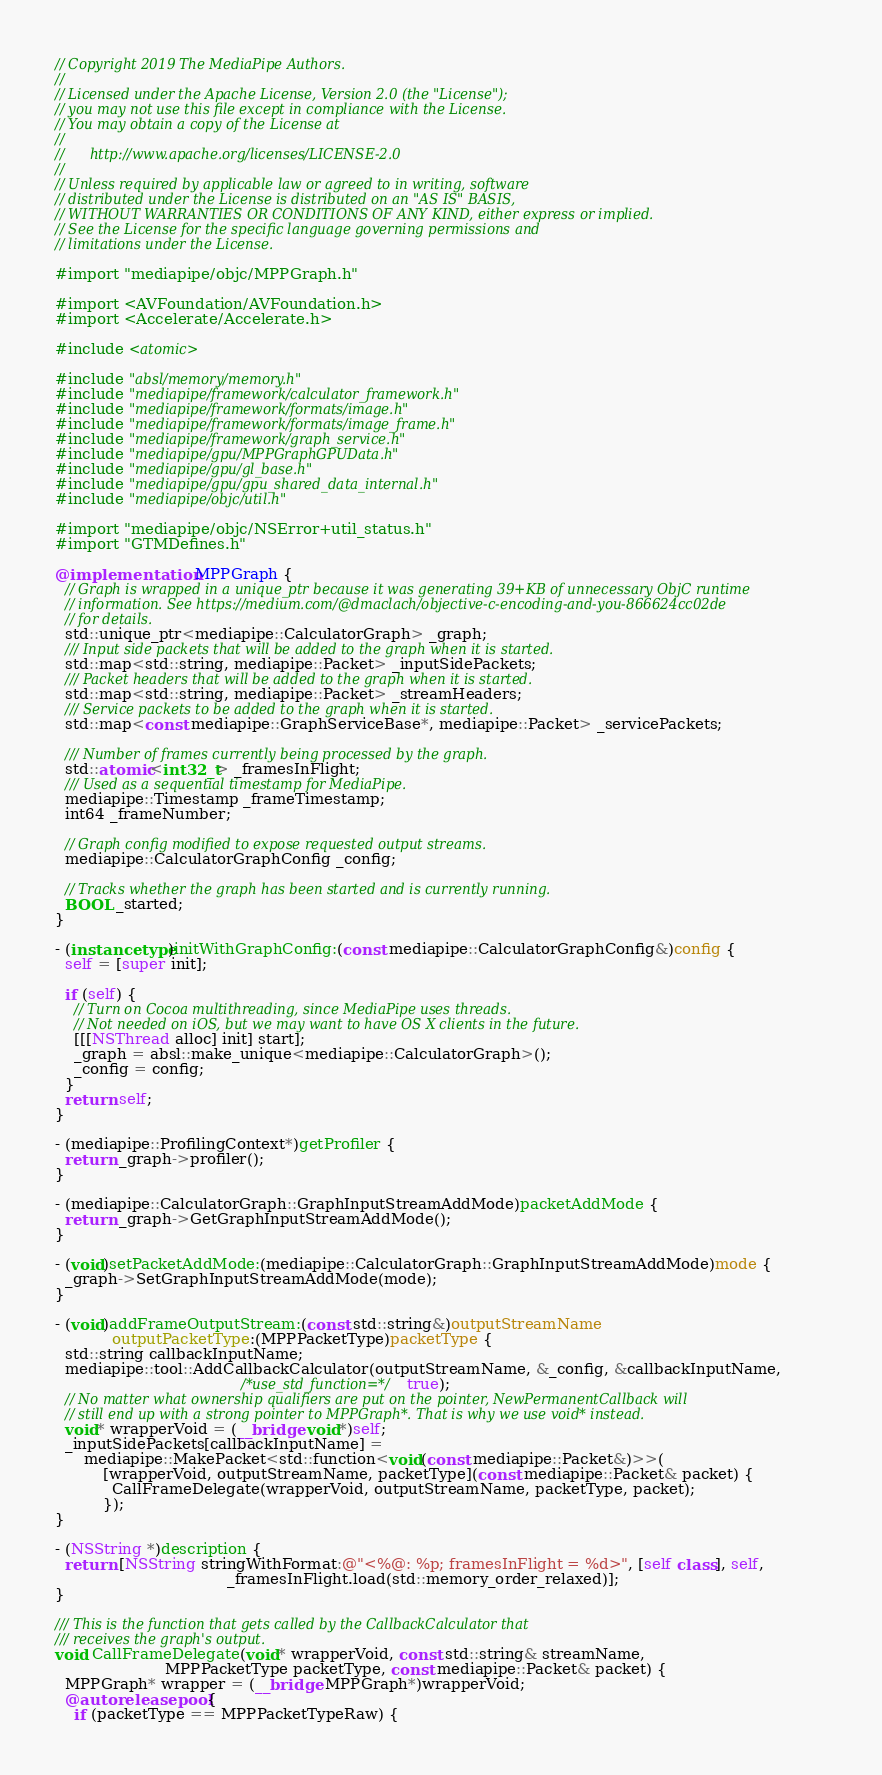<code> <loc_0><loc_0><loc_500><loc_500><_ObjectiveC_>// Copyright 2019 The MediaPipe Authors.
//
// Licensed under the Apache License, Version 2.0 (the "License");
// you may not use this file except in compliance with the License.
// You may obtain a copy of the License at
//
//      http://www.apache.org/licenses/LICENSE-2.0
//
// Unless required by applicable law or agreed to in writing, software
// distributed under the License is distributed on an "AS IS" BASIS,
// WITHOUT WARRANTIES OR CONDITIONS OF ANY KIND, either express or implied.
// See the License for the specific language governing permissions and
// limitations under the License.

#import "mediapipe/objc/MPPGraph.h"

#import <AVFoundation/AVFoundation.h>
#import <Accelerate/Accelerate.h>

#include <atomic>

#include "absl/memory/memory.h"
#include "mediapipe/framework/calculator_framework.h"
#include "mediapipe/framework/formats/image.h"
#include "mediapipe/framework/formats/image_frame.h"
#include "mediapipe/framework/graph_service.h"
#include "mediapipe/gpu/MPPGraphGPUData.h"
#include "mediapipe/gpu/gl_base.h"
#include "mediapipe/gpu/gpu_shared_data_internal.h"
#include "mediapipe/objc/util.h"

#import "mediapipe/objc/NSError+util_status.h"
#import "GTMDefines.h"

@implementation MPPGraph {
  // Graph is wrapped in a unique_ptr because it was generating 39+KB of unnecessary ObjC runtime
  // information. See https://medium.com/@dmaclach/objective-c-encoding-and-you-866624cc02de
  // for details.
  std::unique_ptr<mediapipe::CalculatorGraph> _graph;
  /// Input side packets that will be added to the graph when it is started.
  std::map<std::string, mediapipe::Packet> _inputSidePackets;
  /// Packet headers that will be added to the graph when it is started.
  std::map<std::string, mediapipe::Packet> _streamHeaders;
  /// Service packets to be added to the graph when it is started.
  std::map<const mediapipe::GraphServiceBase*, mediapipe::Packet> _servicePackets;

  /// Number of frames currently being processed by the graph.
  std::atomic<int32_t> _framesInFlight;
  /// Used as a sequential timestamp for MediaPipe.
  mediapipe::Timestamp _frameTimestamp;
  int64 _frameNumber;

  // Graph config modified to expose requested output streams.
  mediapipe::CalculatorGraphConfig _config;

  // Tracks whether the graph has been started and is currently running.
  BOOL _started;
}

- (instancetype)initWithGraphConfig:(const mediapipe::CalculatorGraphConfig&)config {
  self = [super init];

  if (self) {
    // Turn on Cocoa multithreading, since MediaPipe uses threads.
    // Not needed on iOS, but we may want to have OS X clients in the future.
    [[[NSThread alloc] init] start];
    _graph = absl::make_unique<mediapipe::CalculatorGraph>();
    _config = config;
  }
  return self;
}

- (mediapipe::ProfilingContext*)getProfiler {
  return _graph->profiler();
}

- (mediapipe::CalculatorGraph::GraphInputStreamAddMode)packetAddMode {
  return _graph->GetGraphInputStreamAddMode();
}

- (void)setPacketAddMode:(mediapipe::CalculatorGraph::GraphInputStreamAddMode)mode {
  _graph->SetGraphInputStreamAddMode(mode);
}

- (void)addFrameOutputStream:(const std::string&)outputStreamName
            outputPacketType:(MPPPacketType)packetType {
  std::string callbackInputName;
  mediapipe::tool::AddCallbackCalculator(outputStreamName, &_config, &callbackInputName,
                                       /*use_std_function=*/true);
  // No matter what ownership qualifiers are put on the pointer, NewPermanentCallback will
  // still end up with a strong pointer to MPPGraph*. That is why we use void* instead.
  void* wrapperVoid = (__bridge void*)self;
  _inputSidePackets[callbackInputName] =
      mediapipe::MakePacket<std::function<void(const mediapipe::Packet&)>>(
          [wrapperVoid, outputStreamName, packetType](const mediapipe::Packet& packet) {
            CallFrameDelegate(wrapperVoid, outputStreamName, packetType, packet);
          });
}

- (NSString *)description {
  return [NSString stringWithFormat:@"<%@: %p; framesInFlight = %d>", [self class], self,
                                    _framesInFlight.load(std::memory_order_relaxed)];
}

/// This is the function that gets called by the CallbackCalculator that
/// receives the graph's output.
void CallFrameDelegate(void* wrapperVoid, const std::string& streamName,
                       MPPPacketType packetType, const mediapipe::Packet& packet) {
  MPPGraph* wrapper = (__bridge MPPGraph*)wrapperVoid;
  @autoreleasepool {
    if (packetType == MPPPacketTypeRaw) {</code> 